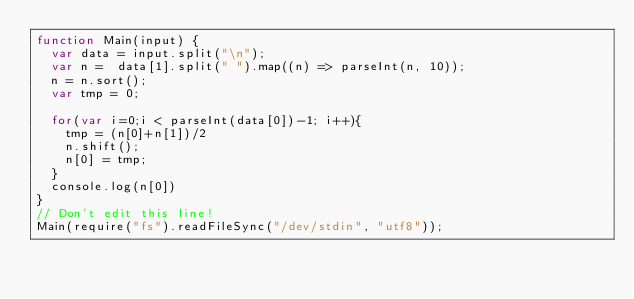Convert code to text. <code><loc_0><loc_0><loc_500><loc_500><_JavaScript_>function Main(input) {
	var data = input.split("\n");
	var n =  data[1].split(" ").map((n) => parseInt(n, 10));
	n = n.sort();
	var tmp = 0;
	
	for(var i=0;i < parseInt(data[0])-1; i++){
		tmp = (n[0]+n[1])/2
		n.shift();
		n[0] = tmp;
	}
	console.log(n[0])
}
// Don't edit this line!
Main(require("fs").readFileSync("/dev/stdin", "utf8"));</code> 